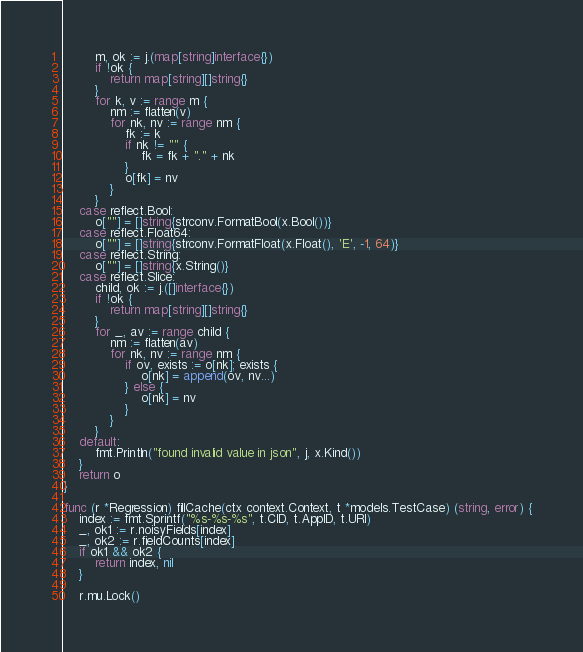<code> <loc_0><loc_0><loc_500><loc_500><_Go_>		m, ok := j.(map[string]interface{})
		if !ok {
			return map[string][]string{}
		}
		for k, v := range m {
			nm := flatten(v)
			for nk, nv := range nm {
				fk := k
				if nk != "" {
					fk = fk + "." + nk
				}
				o[fk] = nv
			}
		}
	case reflect.Bool:
		o[""] = []string{strconv.FormatBool(x.Bool())}
	case reflect.Float64:
		o[""] = []string{strconv.FormatFloat(x.Float(), 'E', -1, 64)}
	case reflect.String:
		o[""] = []string{x.String()}
	case reflect.Slice:
		child, ok := j.([]interface{})
		if !ok {
			return map[string][]string{}
		}
		for _, av := range child {
			nm := flatten(av)
			for nk, nv := range nm {
				if ov, exists := o[nk]; exists {
					o[nk] = append(ov, nv...)
				} else {
					o[nk] = nv
				}
			}
		}
	default:
		fmt.Println("found invalid value in json", j, x.Kind())
	}
	return o
}

func (r *Regression) fillCache(ctx context.Context, t *models.TestCase) (string, error) {
	index := fmt.Sprintf("%s-%s-%s", t.CID, t.AppID, t.URI)
	_, ok1 := r.noisyFields[index]
	_, ok2 := r.fieldCounts[index]
	if ok1 && ok2 {
		return index, nil
	}

	r.mu.Lock()</code> 